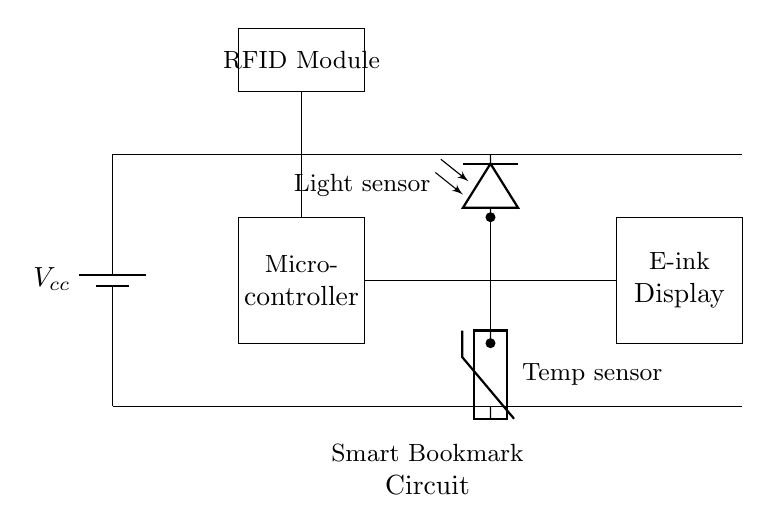What type of microcontroller is used in this circuit? The circuit diagram does not specify the exact type of microcontroller, only indicating a generic microcontroller symbol. In practice, one could choose any low-power microcontroller to suit their needs.
Answer: Microcontroller What components measure ambient conditions? The temperature sensor and the light sensor are responsible for measuring ambient conditions in this circuit. They are specifically connected to the microcontroller for processing the data collected.
Answer: Temperature sensor, light sensor How many power supply connections are shown? There is only one power supply connection represented by the battery symbol. The battery supplies the necessary voltage to the entire circuit.
Answer: One What is the function of the RFID module in this circuit? The RFID module enables the smart bookmark to track reading progress through identification of the books using radio frequency tags. This involves communication with the microcontroller.
Answer: Tracking reading progress What is the voltage label provided in the circuit? The voltage label present in the circuit is labeled as Vcc, which typically denotes the positive supply voltage in electronic circuits. This implies that the components will operate based on this supply voltage.
Answer: Vcc How are the sensors connected to the microcontroller? The temperature and light sensors are connected to the microcontroller through direct lines that signify data transmission for readings and processing. These connections indicate that the microcontroller can read values from these sensors directly.
Answer: Direct connections What type of display is used in this smart bookmark? The circuit diagram specifies the use of an E-ink display, which is commonly used in devices for its low power consumption and high readability in various lighting conditions.
Answer: E-ink display 